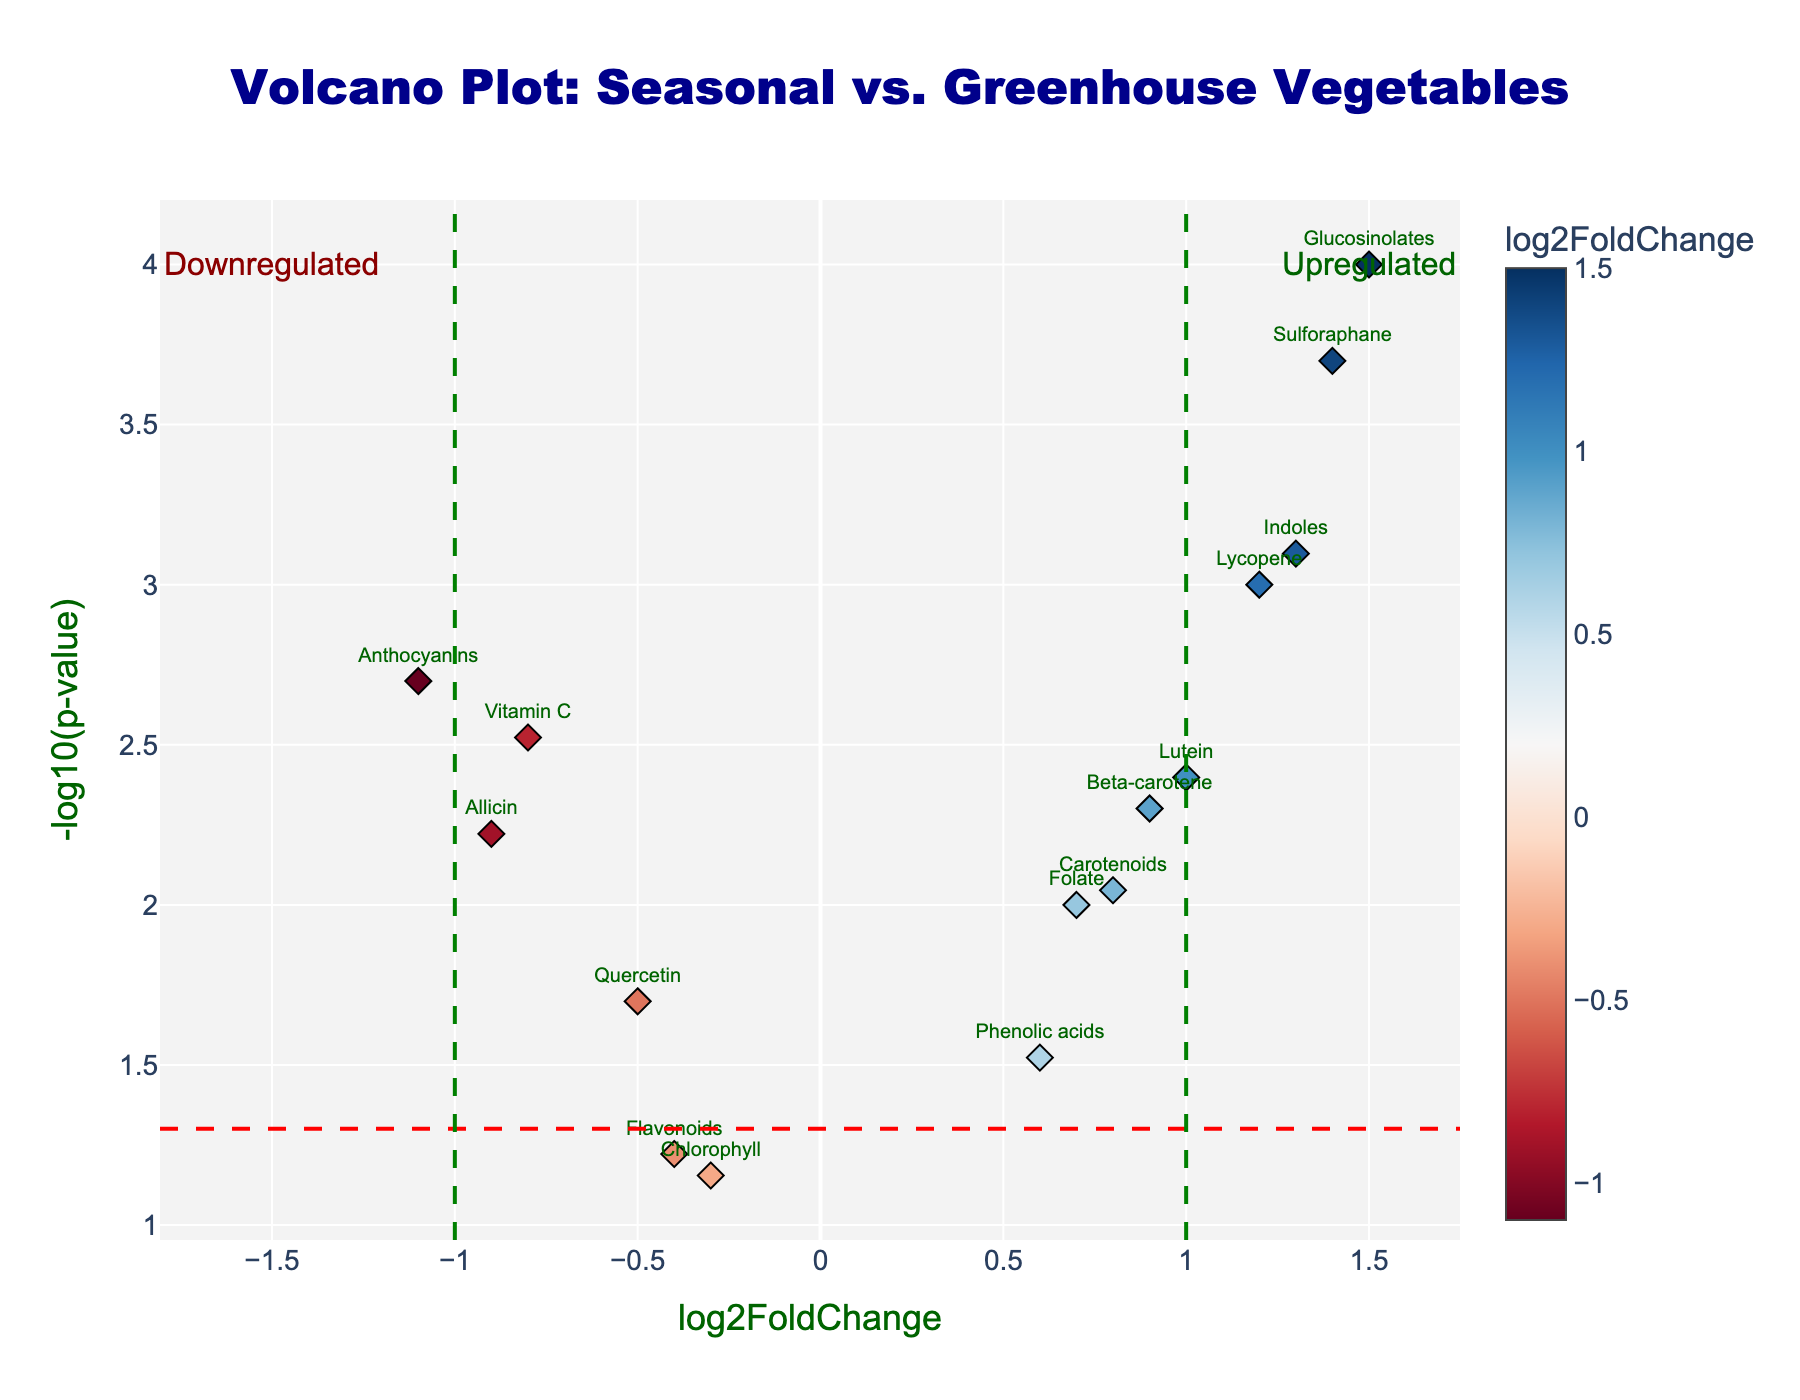How is the Vitamin C metabolite affected in the comparison between seasonal and greenhouse-grown vegetables? The Vitamin C metabolite has a log2FoldChange of -0.8 and a p-value of 0.003. This means Vitamin C is downregulated (log2FoldChange negative) in seasonal vegetables compared to greenhouse-grown vegetables and is statistically significant (p-value < 0.05).
Answer: Downregulated What is the log2FoldChange of the metabolite Lutein? By looking at the plot, Lutein has a log2FoldChange of 1.0, indicated directly next to its data point.
Answer: 1.0 Which metabolite has the highest negative log2FoldChange value, indicating it is the most downregulated? Anthocyanins have the highest negative log2FoldChange value at -1.1. This indicates it is the most downregulated metabolite in seasonal vegetables compared to greenhouse-grown ones.
Answer: Anthocyanins What is the significance threshold used in the figure? The significance threshold is represented by a red dashed horizontal line at y = -log10(0.05), which equals 1.3. Metabolites above this line have p-values less than 0.05 and are statistically significant.
Answer: 0.05 Which metabolites are significantly upregulated (log2FoldChange > 1 and p-value < 0.05)? Glucosinolates, Lycopene, Indoles, and Sulforaphane are significantly upregulated, as they all have log2FoldChange > 1 and are above the significance threshold line (p-value < 0.05).
Answer: Glucosinolates, Lycopene, Indoles, Sulforaphane How many metabolites have a p-value greater than 0.05? By checking the vertical position of the metabolites in the plot, Flavonoids and Chlorophyll are below the significance threshold line, thus their p-values are greater than 0.05.
Answer: 2 Which metabolite has the lowest p-value and what does this indicate about its regulation? Glucosinolates have the lowest p-value (0.0001), indicated by the highest point on the y-axis (-log10 p-value ~ 4). This means the change in Glucosinolates is highly statistically significant.
Answer: Glucosinolates Of the metabolites with a log2FoldChange greater than 0.5, which one has the largest p-value? Phenolic acids have a log2FoldChange of 0.6 and the largest p-value (0.03) among metabolites with log2FoldChange > 0.5.
Answer: Phenolic acids 